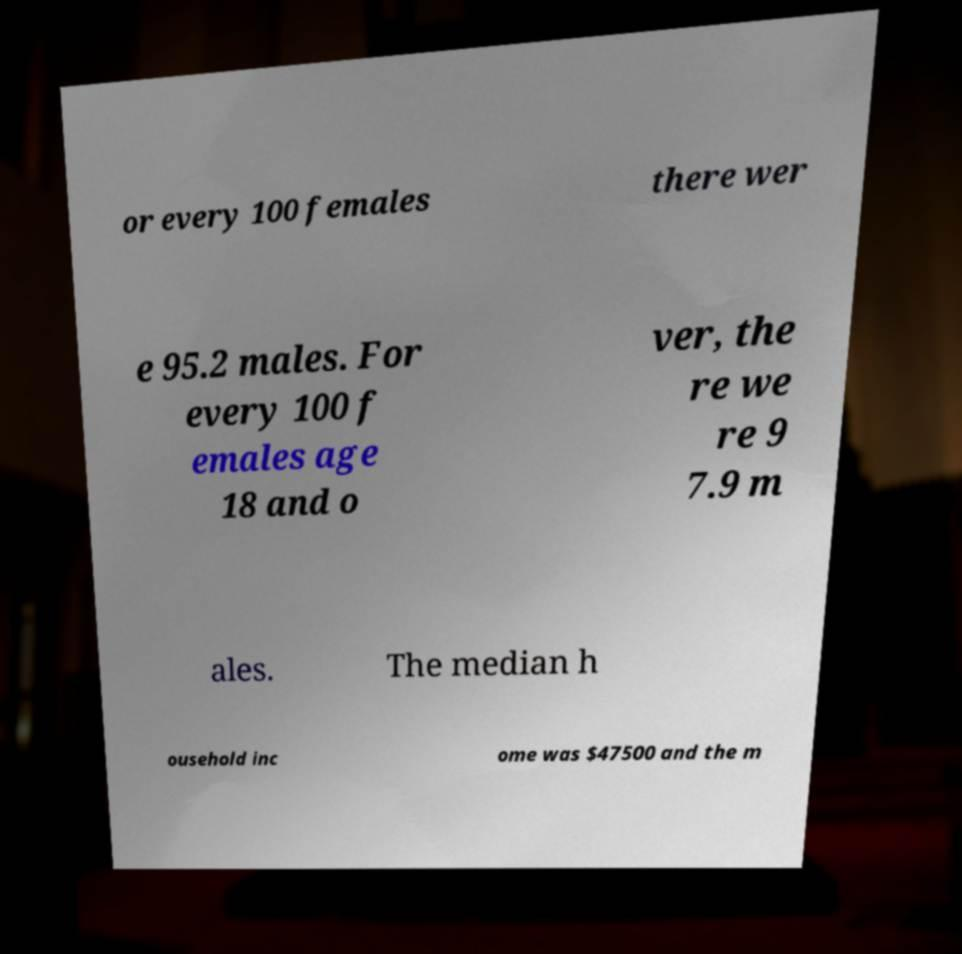Please read and relay the text visible in this image. What does it say? or every 100 females there wer e 95.2 males. For every 100 f emales age 18 and o ver, the re we re 9 7.9 m ales. The median h ousehold inc ome was $47500 and the m 